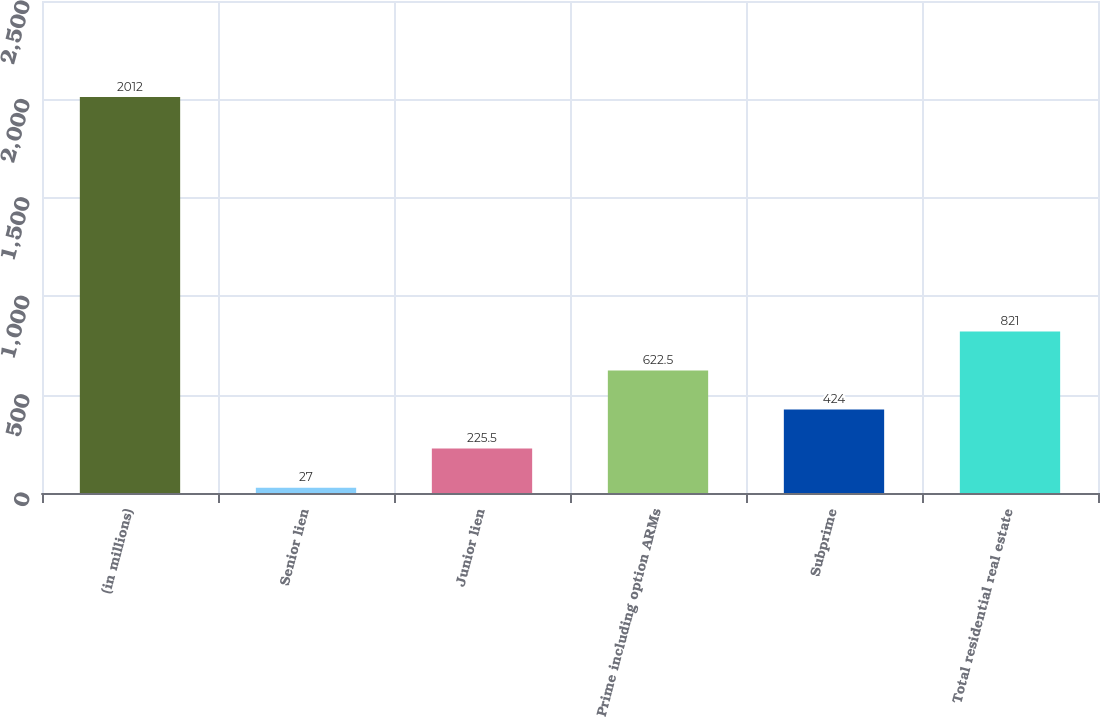Convert chart. <chart><loc_0><loc_0><loc_500><loc_500><bar_chart><fcel>(in millions)<fcel>Senior lien<fcel>Junior lien<fcel>Prime including option ARMs<fcel>Subprime<fcel>Total residential real estate<nl><fcel>2012<fcel>27<fcel>225.5<fcel>622.5<fcel>424<fcel>821<nl></chart> 